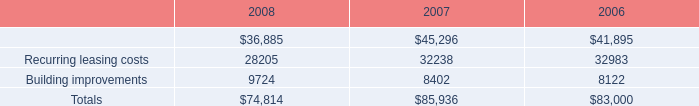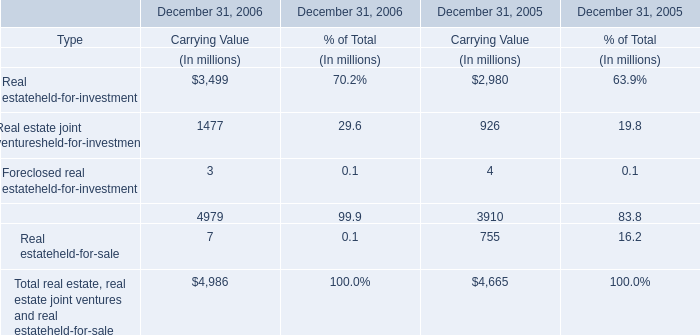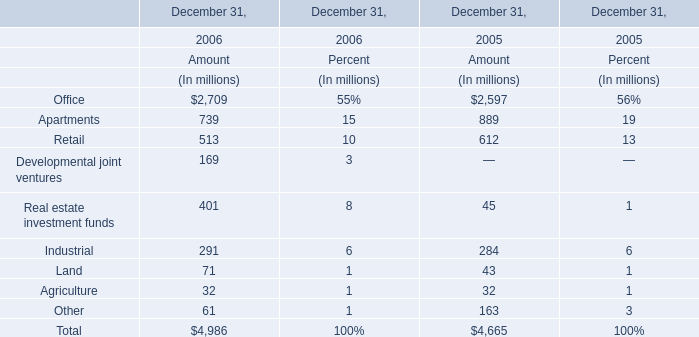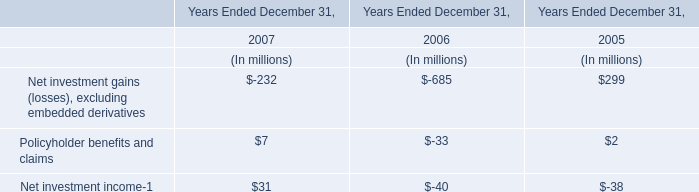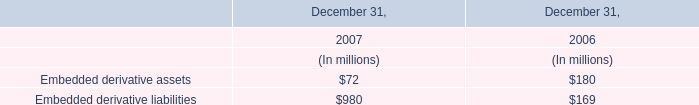What is the total value of Office,Apartments, Retail and Developmental joint ventures in 2006? (in million) 
Computations: (((2709 + 739) + 513) + 169)
Answer: 4130.0. 